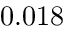Convert formula to latex. <formula><loc_0><loc_0><loc_500><loc_500>0 . 0 1 8</formula> 